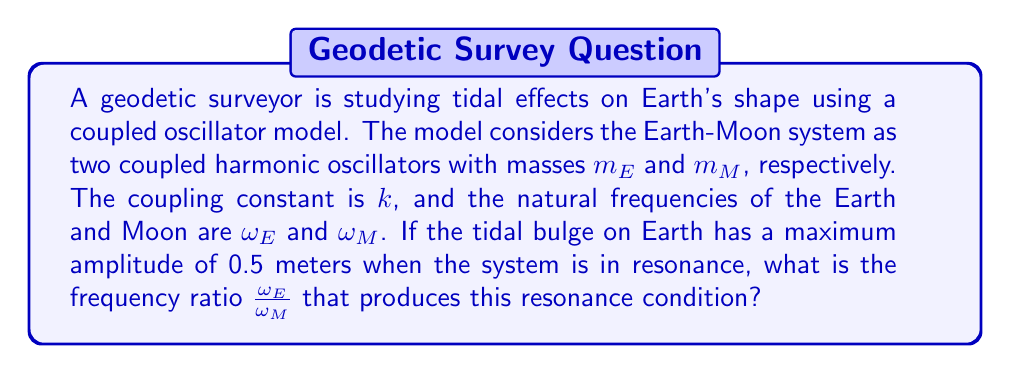Can you answer this question? To solve this problem, we'll follow these steps:

1) In a coupled oscillator system, resonance occurs when the driving frequency matches one of the normal mode frequencies. For a two-mass system, there are two normal modes.

2) The normal mode frequencies for a coupled two-mass system are given by:

   $$\omega_{\pm}^2 = \frac{1}{2}\left[(\omega_E^2 + \omega_M^2) \pm \sqrt{(\omega_E^2 - \omega_M^2)^2 + 4\frac{k^2}{m_E m_M}}\right]$$

3) Resonance occurs when the driving frequency matches either $\omega_+$ or $\omega_-$. The condition for maximum amplitude (resonance) is when:

   $$\omega_E^2 = \omega_M^2$$

4) This condition simplifies the normal mode frequency equation to:

   $$\omega_{\pm}^2 = \omega_E^2 \pm \frac{k}{\sqrt{m_E m_M}}$$

5) The resonance condition implies that:

   $$\frac{\omega_E}{\omega_M} = 1$$

Therefore, the frequency ratio that produces the resonance condition, resulting in the maximum tidal bulge amplitude of 0.5 meters, is 1.
Answer: 1 